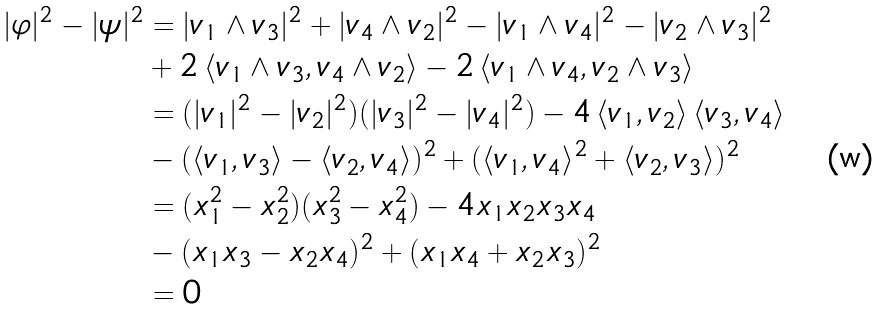Convert formula to latex. <formula><loc_0><loc_0><loc_500><loc_500>| \varphi | ^ { 2 } - | \psi | ^ { 2 } & = | v _ { 1 } \wedge v _ { 3 } | ^ { 2 } + | v _ { 4 } \wedge v _ { 2 } | ^ { 2 } - | v _ { 1 } \wedge v _ { 4 } | ^ { 2 } - | v _ { 2 } \wedge v _ { 3 } | ^ { 2 } \\ & + 2 \, \langle v _ { 1 } \wedge v _ { 3 } , v _ { 4 } \wedge v _ { 2 } \rangle - 2 \, \langle v _ { 1 } \wedge v _ { 4 } , v _ { 2 } \wedge v _ { 3 } \rangle \\ & = ( | v _ { 1 } | ^ { 2 } - | v _ { 2 } | ^ { 2 } ) ( | v _ { 3 } | ^ { 2 } - | v _ { 4 } | ^ { 2 } ) - 4 \, \langle v _ { 1 } , v _ { 2 } \rangle \, \langle v _ { 3 } , v _ { 4 } \rangle \\ & - ( \langle v _ { 1 } , v _ { 3 } \rangle - \langle v _ { 2 } , v _ { 4 } \rangle ) ^ { 2 } + ( \langle v _ { 1 } , v _ { 4 } \rangle ^ { 2 } + \langle v _ { 2 } , v _ { 3 } \rangle ) ^ { 2 } \\ & = ( x _ { 1 } ^ { 2 } - x _ { 2 } ^ { 2 } ) ( x _ { 3 } ^ { 2 } - x _ { 4 } ^ { 2 } ) - 4 x _ { 1 } x _ { 2 } x _ { 3 } x _ { 4 } \\ & - ( x _ { 1 } x _ { 3 } - x _ { 2 } x _ { 4 } ) ^ { 2 } + ( x _ { 1 } x _ { 4 } + x _ { 2 } x _ { 3 } ) ^ { 2 } \\ & = 0</formula> 